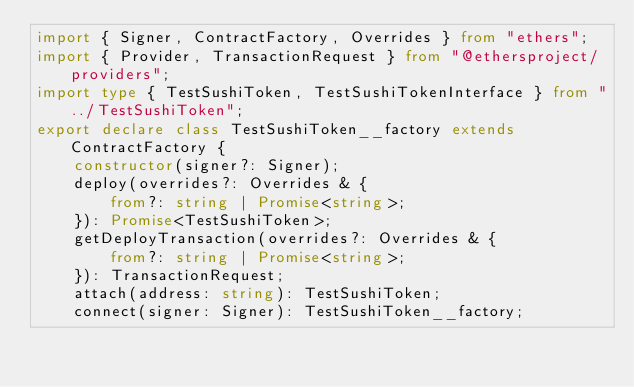Convert code to text. <code><loc_0><loc_0><loc_500><loc_500><_TypeScript_>import { Signer, ContractFactory, Overrides } from "ethers";
import { Provider, TransactionRequest } from "@ethersproject/providers";
import type { TestSushiToken, TestSushiTokenInterface } from "../TestSushiToken";
export declare class TestSushiToken__factory extends ContractFactory {
    constructor(signer?: Signer);
    deploy(overrides?: Overrides & {
        from?: string | Promise<string>;
    }): Promise<TestSushiToken>;
    getDeployTransaction(overrides?: Overrides & {
        from?: string | Promise<string>;
    }): TransactionRequest;
    attach(address: string): TestSushiToken;
    connect(signer: Signer): TestSushiToken__factory;</code> 